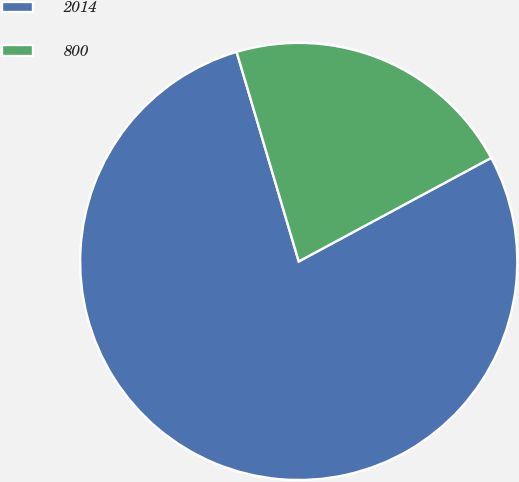<chart> <loc_0><loc_0><loc_500><loc_500><pie_chart><fcel>2014<fcel>800<nl><fcel>78.27%<fcel>21.73%<nl></chart> 